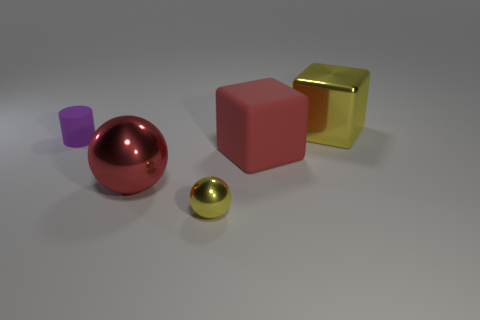Add 2 cyan spheres. How many objects exist? 7 Subtract all balls. How many objects are left? 3 Add 4 small purple rubber objects. How many small purple rubber objects are left? 5 Add 2 big red matte cubes. How many big red matte cubes exist? 3 Subtract all yellow spheres. How many spheres are left? 1 Subtract 0 brown spheres. How many objects are left? 5 Subtract 1 balls. How many balls are left? 1 Subtract all green blocks. Subtract all blue balls. How many blocks are left? 2 Subtract all brown cylinders. How many gray blocks are left? 0 Subtract all tiny red shiny blocks. Subtract all large balls. How many objects are left? 4 